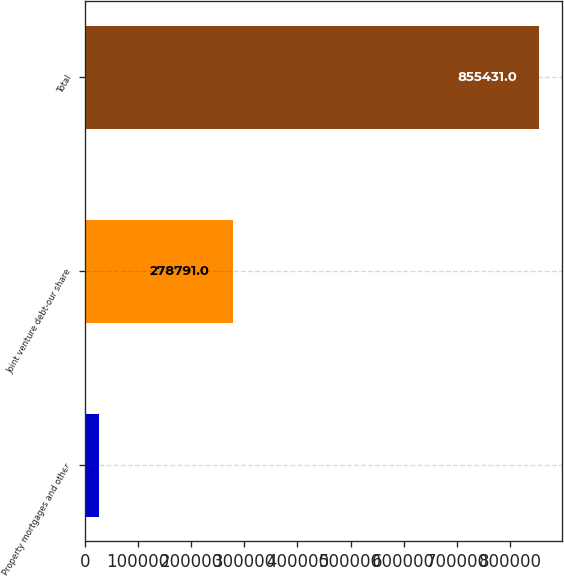Convert chart. <chart><loc_0><loc_0><loc_500><loc_500><bar_chart><fcel>Property mortgages and other<fcel>Joint venture debt-our share<fcel>Total<nl><fcel>26640<fcel>278791<fcel>855431<nl></chart> 